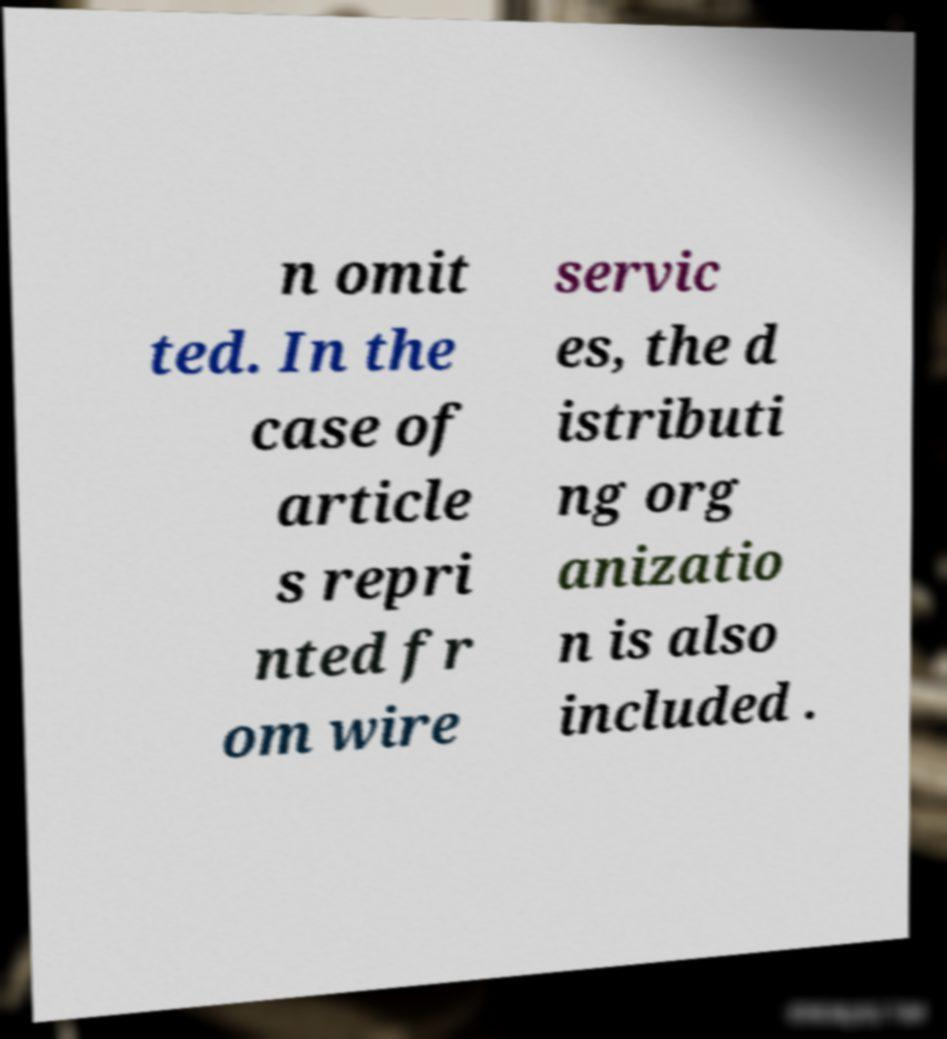Please read and relay the text visible in this image. What does it say? n omit ted. In the case of article s repri nted fr om wire servic es, the d istributi ng org anizatio n is also included . 